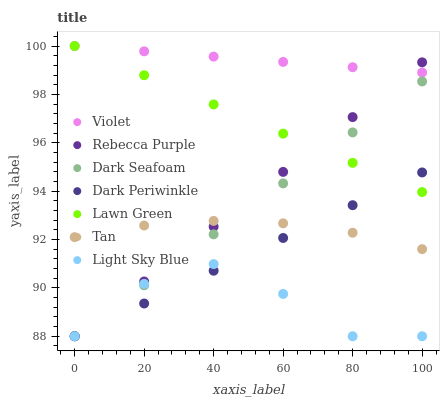Does Light Sky Blue have the minimum area under the curve?
Answer yes or no. Yes. Does Violet have the maximum area under the curve?
Answer yes or no. Yes. Does Dark Seafoam have the minimum area under the curve?
Answer yes or no. No. Does Dark Seafoam have the maximum area under the curve?
Answer yes or no. No. Is Dark Seafoam the smoothest?
Answer yes or no. Yes. Is Light Sky Blue the roughest?
Answer yes or no. Yes. Is Light Sky Blue the smoothest?
Answer yes or no. No. Is Dark Seafoam the roughest?
Answer yes or no. No. Does Dark Seafoam have the lowest value?
Answer yes or no. Yes. Does Violet have the lowest value?
Answer yes or no. No. Does Violet have the highest value?
Answer yes or no. Yes. Does Dark Seafoam have the highest value?
Answer yes or no. No. Is Light Sky Blue less than Lawn Green?
Answer yes or no. Yes. Is Violet greater than Light Sky Blue?
Answer yes or no. Yes. Does Light Sky Blue intersect Rebecca Purple?
Answer yes or no. Yes. Is Light Sky Blue less than Rebecca Purple?
Answer yes or no. No. Is Light Sky Blue greater than Rebecca Purple?
Answer yes or no. No. Does Light Sky Blue intersect Lawn Green?
Answer yes or no. No. 